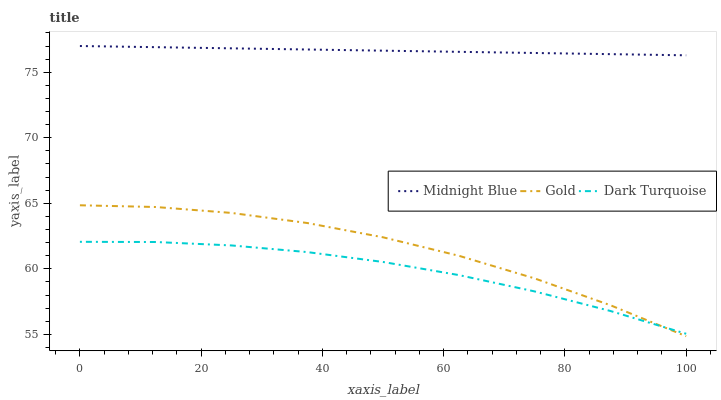Does Dark Turquoise have the minimum area under the curve?
Answer yes or no. Yes. Does Midnight Blue have the maximum area under the curve?
Answer yes or no. Yes. Does Gold have the minimum area under the curve?
Answer yes or no. No. Does Gold have the maximum area under the curve?
Answer yes or no. No. Is Midnight Blue the smoothest?
Answer yes or no. Yes. Is Gold the roughest?
Answer yes or no. Yes. Is Gold the smoothest?
Answer yes or no. No. Is Midnight Blue the roughest?
Answer yes or no. No. Does Gold have the lowest value?
Answer yes or no. Yes. Does Midnight Blue have the lowest value?
Answer yes or no. No. Does Midnight Blue have the highest value?
Answer yes or no. Yes. Does Gold have the highest value?
Answer yes or no. No. Is Dark Turquoise less than Midnight Blue?
Answer yes or no. Yes. Is Midnight Blue greater than Gold?
Answer yes or no. Yes. Does Gold intersect Dark Turquoise?
Answer yes or no. Yes. Is Gold less than Dark Turquoise?
Answer yes or no. No. Is Gold greater than Dark Turquoise?
Answer yes or no. No. Does Dark Turquoise intersect Midnight Blue?
Answer yes or no. No. 